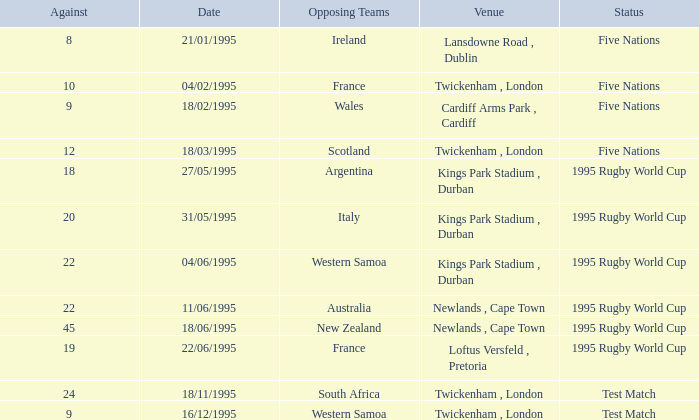What's the total against for opposing team scotland at twickenham, london venue with a status of five nations? 1.0. 